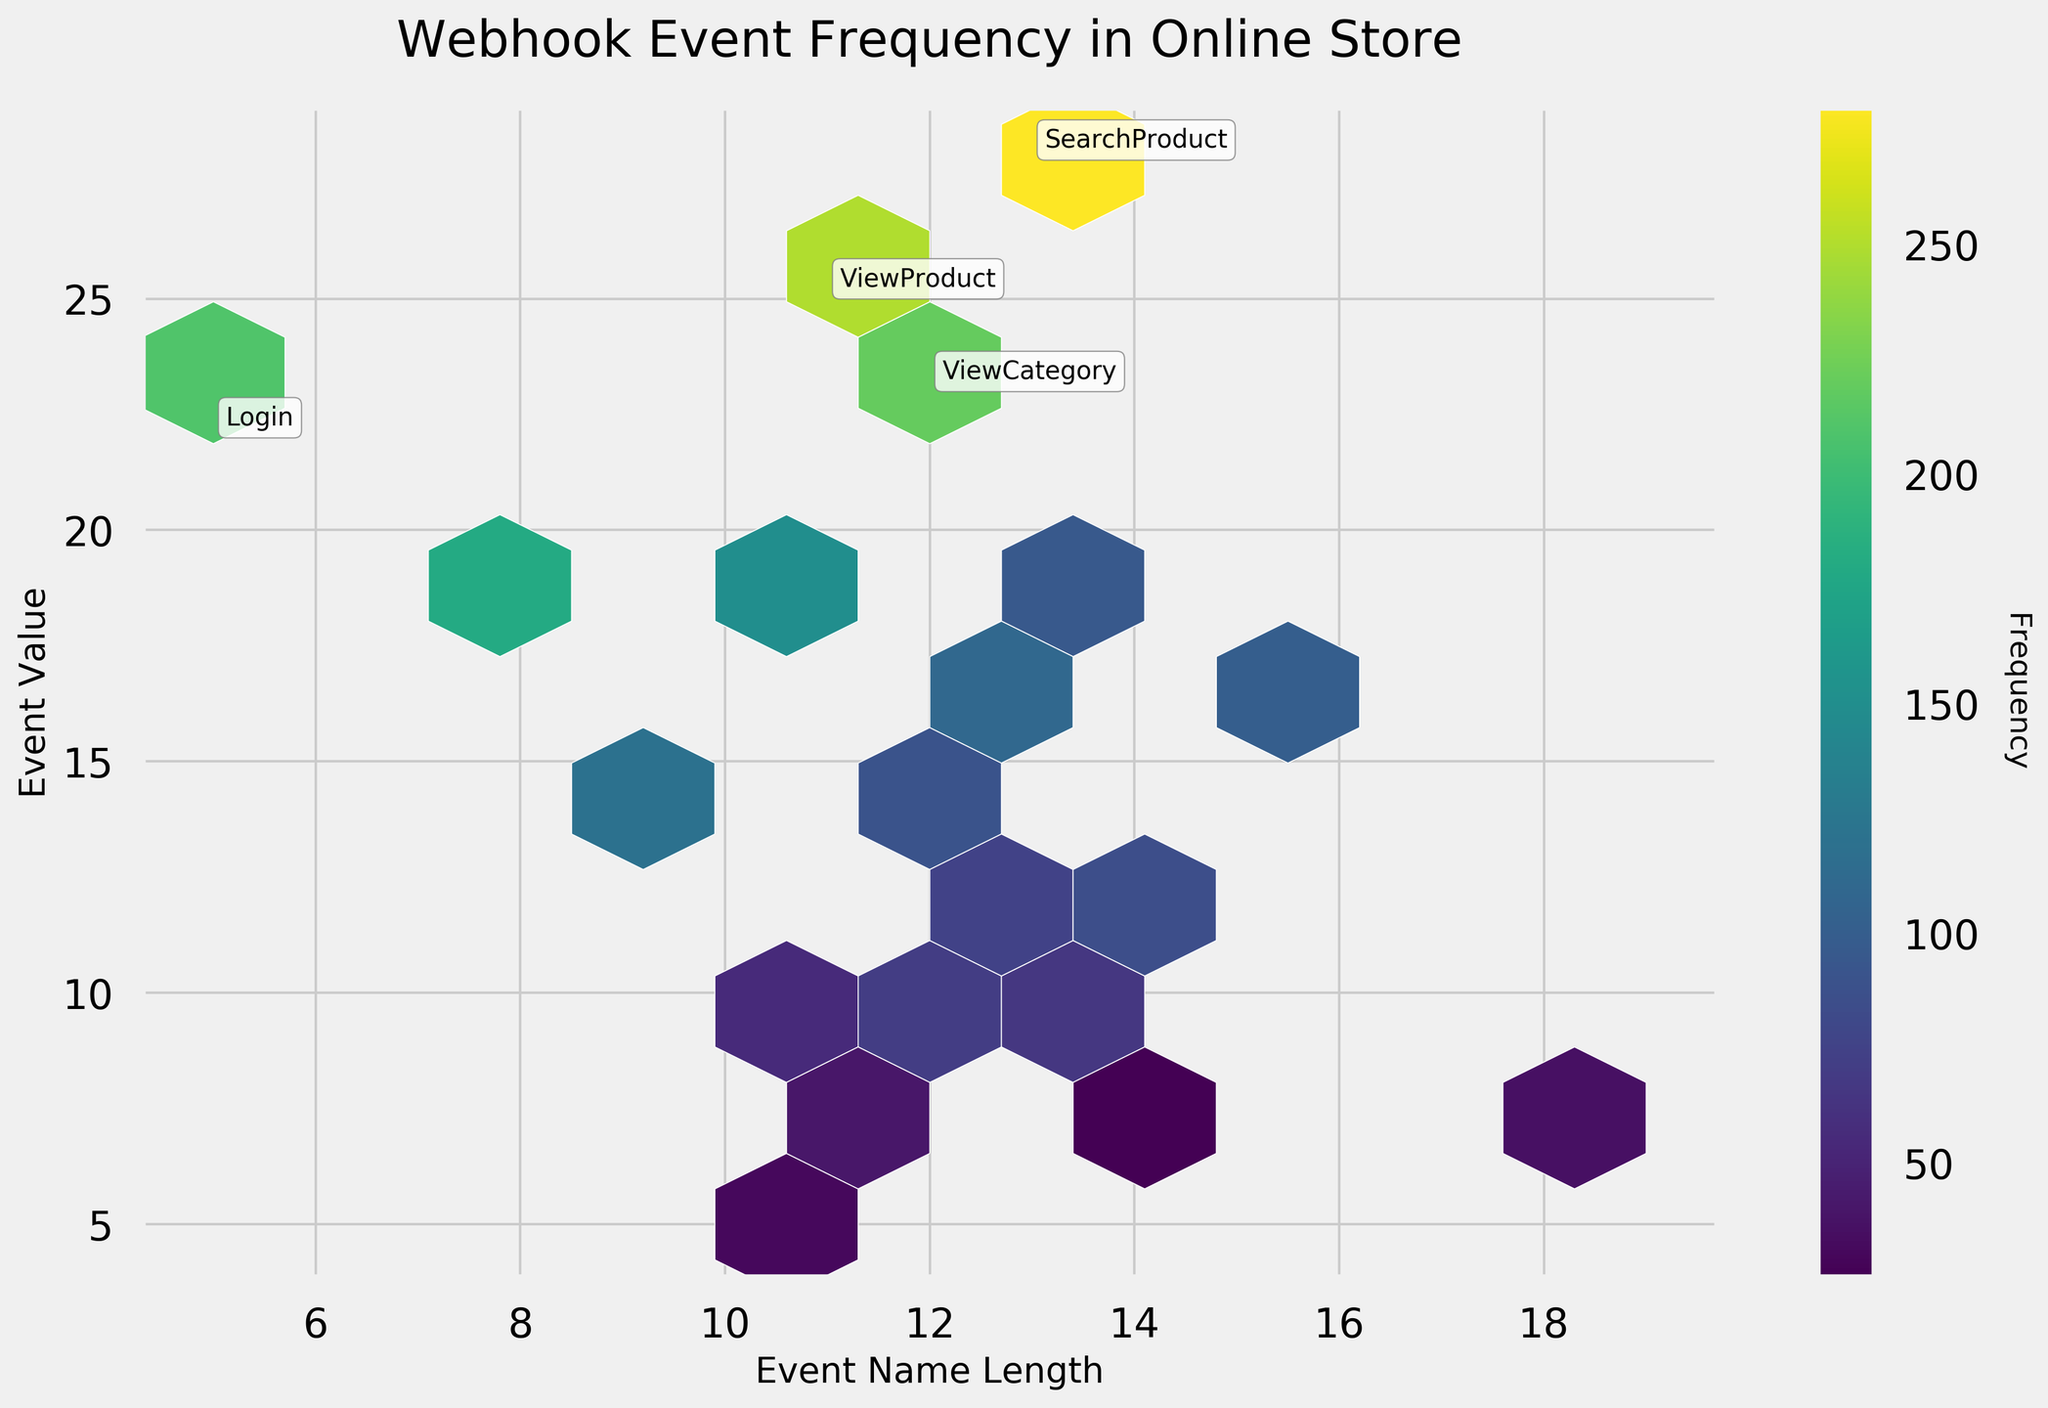How many webhook events were plotted on the hexbin plot? The figure contains one hexagonal bin for each unique webhook event, which is defined by the different event names on the x-axis. Counting the unique event names will give the number of webhook events.
Answer: 20 What are the most frequently triggered webhook events? Identify hexagons with the highest color intensity and annotations. The most intense regions on the color bar represent events with frequencies above 200. Annotated events like 'ViewProduct,' 'SearchProduct,' and 'ViewCategory' indicate high frequency.
Answer: ViewProduct, SearchProduct, ViewCategory Which event has the longest name and what is its frequency? Examine the x-axis which represents the length of event names. The event with the largest x-value should have the longest name. The frequency can be verified by looking at the color intensity for that point.
Answer: SubscribeNewsletter, 35 What is the relationship between event name length and event frequency? The plot uses event name length on the x-axis and frequency indicated by color intensity. Observing the overall pattern, events with moderate to high length names and color intensity suggests a correlation.
Answer: Moderate correlation Which webhook event has the highest frequency and what is its length? Check the highest color intensity on the color bar and the annotated hexbin for events with frequency above 200. Then find the length of that event name.
Answer: SearchProduct, 13 Are there more webhook events with high frequencies (e.g., above 200) or low frequencies (e.g., below 50)? Count events with colors representing frequencies above and below the threshold on the color bar. Annotated points and the majority of hexagons will indicate the answer.
Answer: High frequencies How many webhook events trigger between 75 and 150 times? Check the color gradient on the plot corresponding to the frequencies between 75 and 150 and count the hexagons within this range.
Answer: 7 Compare the event frequencies of 'AddToCart' and 'RemoveFromCart'. Which one is higher? Locate hexagons for 'AddToCart' and 'RemoveFromCart' and compare their color intensities. The color bar shows relative frequencies.
Answer: AddToCart is higher What is the frequency range shown by the color bar in the plot? Observe the intervals on the color bar from the beginning to the end. This will indicate the overall range of frequencies plotted.
Answer: 25 to 280 Which event has the shortest name, and what is its frequency? Find the event with the smallest x-value, indicating the shortest name. Then check the color intensity for that event to determine its frequency.
Answer: Login, 210 